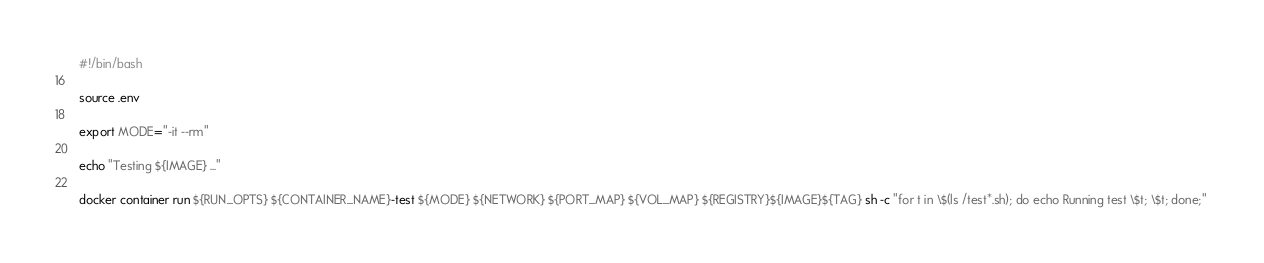<code> <loc_0><loc_0><loc_500><loc_500><_Bash_>#!/bin/bash

source .env

export MODE="-it --rm"

echo "Testing ${IMAGE} ..."

docker container run ${RUN_OPTS} ${CONTAINER_NAME}-test ${MODE} ${NETWORK} ${PORT_MAP} ${VOL_MAP} ${REGISTRY}${IMAGE}${TAG} sh -c "for t in \$(ls /test*.sh); do echo Running test \$t; \$t; done;" 


</code> 